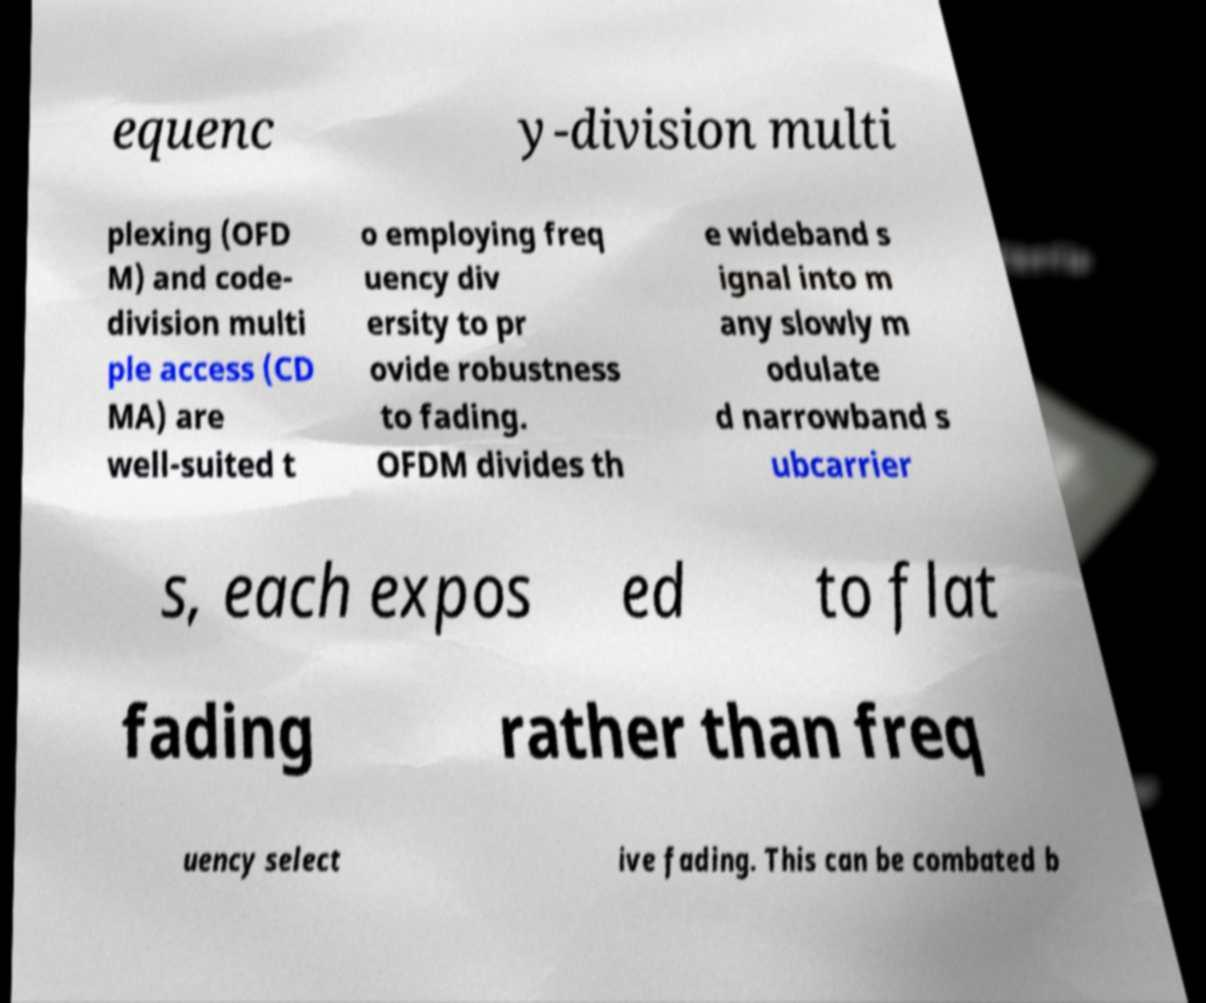For documentation purposes, I need the text within this image transcribed. Could you provide that? equenc y-division multi plexing (OFD M) and code- division multi ple access (CD MA) are well-suited t o employing freq uency div ersity to pr ovide robustness to fading. OFDM divides th e wideband s ignal into m any slowly m odulate d narrowband s ubcarrier s, each expos ed to flat fading rather than freq uency select ive fading. This can be combated b 